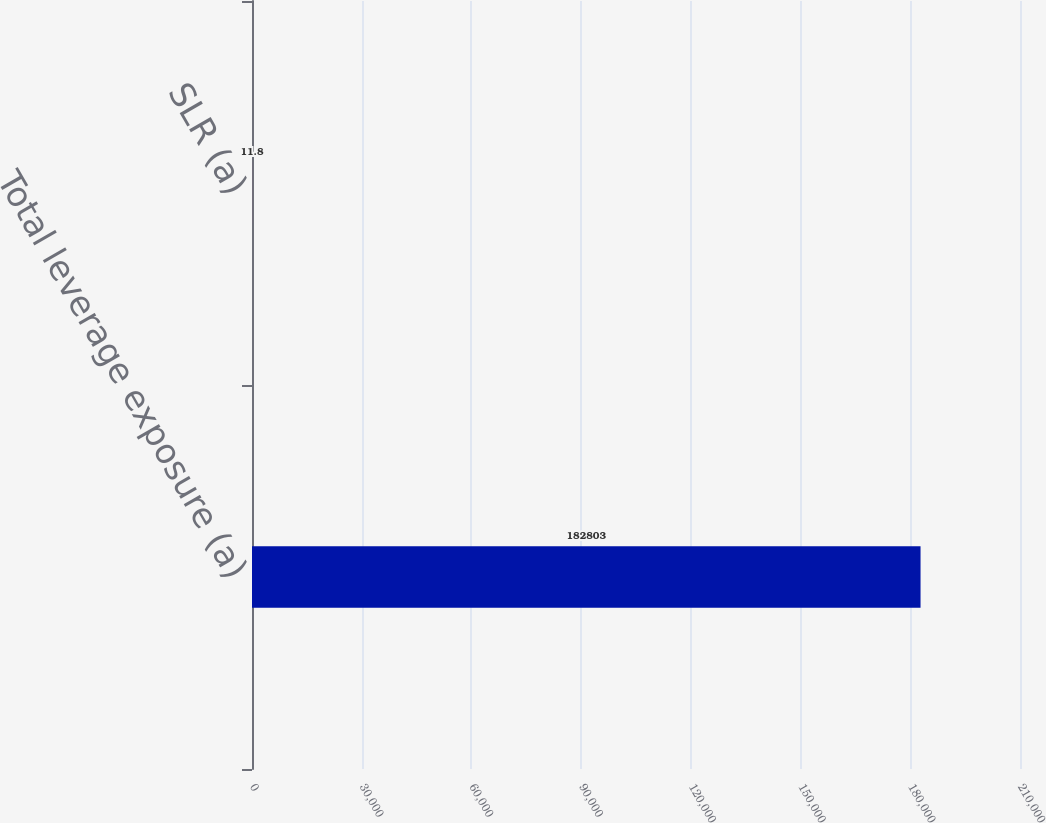<chart> <loc_0><loc_0><loc_500><loc_500><bar_chart><fcel>Total leverage exposure (a)<fcel>SLR (a)<nl><fcel>182803<fcel>11.8<nl></chart> 